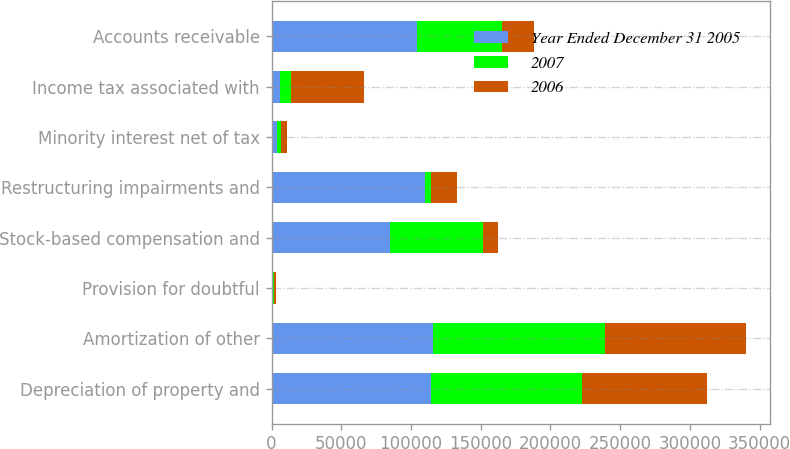Convert chart to OTSL. <chart><loc_0><loc_0><loc_500><loc_500><stacked_bar_chart><ecel><fcel>Depreciation of property and<fcel>Amortization of other<fcel>Provision for doubtful<fcel>Stock-based compensation and<fcel>Restructuring impairments and<fcel>Minority interest net of tax<fcel>Income tax associated with<fcel>Accounts receivable<nl><fcel>Year Ended December 31 2005<fcel>114539<fcel>116064<fcel>850<fcel>85250<fcel>110110<fcel>3840<fcel>6189<fcel>104338<nl><fcel>2007<fcel>108349<fcel>122767<fcel>1165<fcel>66285<fcel>4471<fcel>2875<fcel>7833<fcel>61263<nl><fcel>2006<fcel>89309<fcel>101638<fcel>1041<fcel>10588<fcel>18703<fcel>4702<fcel>51964<fcel>22665<nl></chart> 